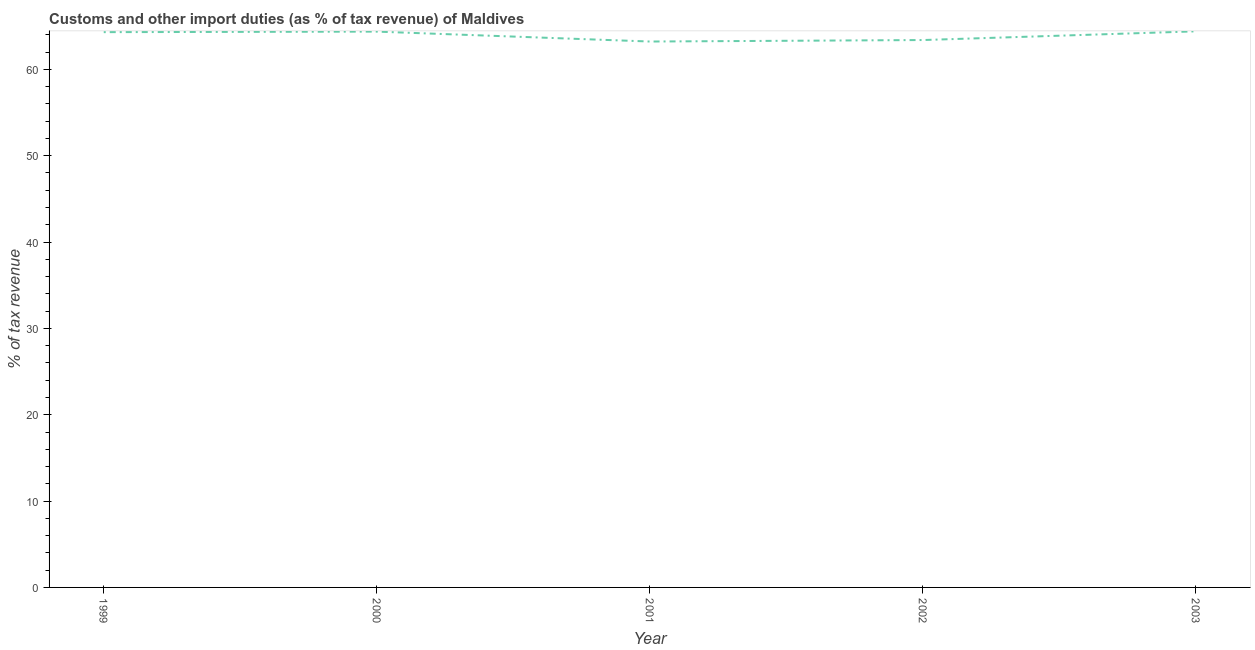What is the customs and other import duties in 2001?
Ensure brevity in your answer.  63.22. Across all years, what is the maximum customs and other import duties?
Provide a short and direct response. 64.4. Across all years, what is the minimum customs and other import duties?
Your answer should be compact. 63.22. In which year was the customs and other import duties minimum?
Keep it short and to the point. 2001. What is the sum of the customs and other import duties?
Offer a very short reply. 319.71. What is the difference between the customs and other import duties in 2000 and 2001?
Your answer should be compact. 1.15. What is the average customs and other import duties per year?
Your answer should be very brief. 63.94. What is the median customs and other import duties?
Give a very brief answer. 64.31. In how many years, is the customs and other import duties greater than 26 %?
Your response must be concise. 5. Do a majority of the years between 1999 and 2000 (inclusive) have customs and other import duties greater than 10 %?
Keep it short and to the point. Yes. What is the ratio of the customs and other import duties in 2000 to that in 2003?
Keep it short and to the point. 1. Is the customs and other import duties in 2000 less than that in 2001?
Your response must be concise. No. Is the difference between the customs and other import duties in 1999 and 2001 greater than the difference between any two years?
Ensure brevity in your answer.  No. What is the difference between the highest and the second highest customs and other import duties?
Your response must be concise. 0.03. Is the sum of the customs and other import duties in 1999 and 2002 greater than the maximum customs and other import duties across all years?
Your answer should be compact. Yes. What is the difference between the highest and the lowest customs and other import duties?
Ensure brevity in your answer.  1.18. Does the customs and other import duties monotonically increase over the years?
Provide a short and direct response. No. How many years are there in the graph?
Offer a terse response. 5. What is the difference between two consecutive major ticks on the Y-axis?
Make the answer very short. 10. Are the values on the major ticks of Y-axis written in scientific E-notation?
Provide a short and direct response. No. Does the graph contain any zero values?
Provide a short and direct response. No. What is the title of the graph?
Your response must be concise. Customs and other import duties (as % of tax revenue) of Maldives. What is the label or title of the Y-axis?
Offer a very short reply. % of tax revenue. What is the % of tax revenue in 1999?
Your answer should be very brief. 64.31. What is the % of tax revenue of 2000?
Ensure brevity in your answer.  64.37. What is the % of tax revenue of 2001?
Your answer should be compact. 63.22. What is the % of tax revenue of 2002?
Ensure brevity in your answer.  63.4. What is the % of tax revenue in 2003?
Offer a terse response. 64.4. What is the difference between the % of tax revenue in 1999 and 2000?
Give a very brief answer. -0.06. What is the difference between the % of tax revenue in 1999 and 2001?
Provide a short and direct response. 1.09. What is the difference between the % of tax revenue in 1999 and 2002?
Keep it short and to the point. 0.91. What is the difference between the % of tax revenue in 1999 and 2003?
Your answer should be very brief. -0.09. What is the difference between the % of tax revenue in 2000 and 2001?
Provide a short and direct response. 1.15. What is the difference between the % of tax revenue in 2000 and 2002?
Provide a short and direct response. 0.98. What is the difference between the % of tax revenue in 2000 and 2003?
Provide a short and direct response. -0.03. What is the difference between the % of tax revenue in 2001 and 2002?
Keep it short and to the point. -0.17. What is the difference between the % of tax revenue in 2001 and 2003?
Provide a short and direct response. -1.18. What is the difference between the % of tax revenue in 2002 and 2003?
Your answer should be very brief. -1.01. What is the ratio of the % of tax revenue in 2000 to that in 2002?
Your answer should be compact. 1.01. What is the ratio of the % of tax revenue in 2000 to that in 2003?
Offer a terse response. 1. What is the ratio of the % of tax revenue in 2001 to that in 2002?
Your answer should be very brief. 1. What is the ratio of the % of tax revenue in 2001 to that in 2003?
Provide a succinct answer. 0.98. What is the ratio of the % of tax revenue in 2002 to that in 2003?
Your answer should be very brief. 0.98. 